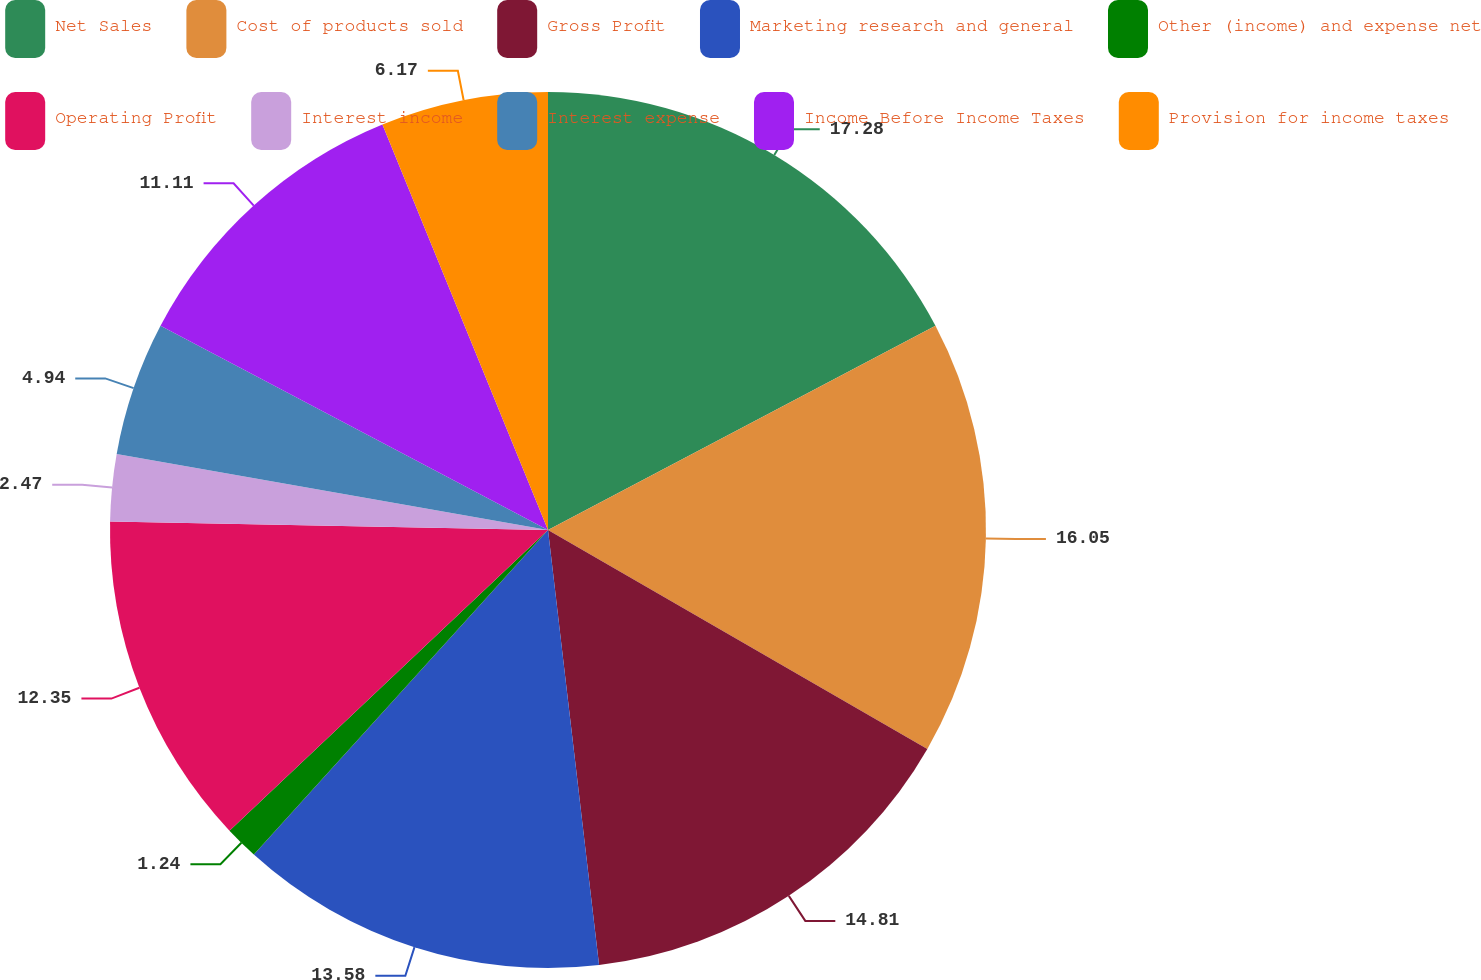Convert chart to OTSL. <chart><loc_0><loc_0><loc_500><loc_500><pie_chart><fcel>Net Sales<fcel>Cost of products sold<fcel>Gross Profit<fcel>Marketing research and general<fcel>Other (income) and expense net<fcel>Operating Profit<fcel>Interest income<fcel>Interest expense<fcel>Income Before Income Taxes<fcel>Provision for income taxes<nl><fcel>17.28%<fcel>16.05%<fcel>14.81%<fcel>13.58%<fcel>1.24%<fcel>12.35%<fcel>2.47%<fcel>4.94%<fcel>11.11%<fcel>6.17%<nl></chart> 